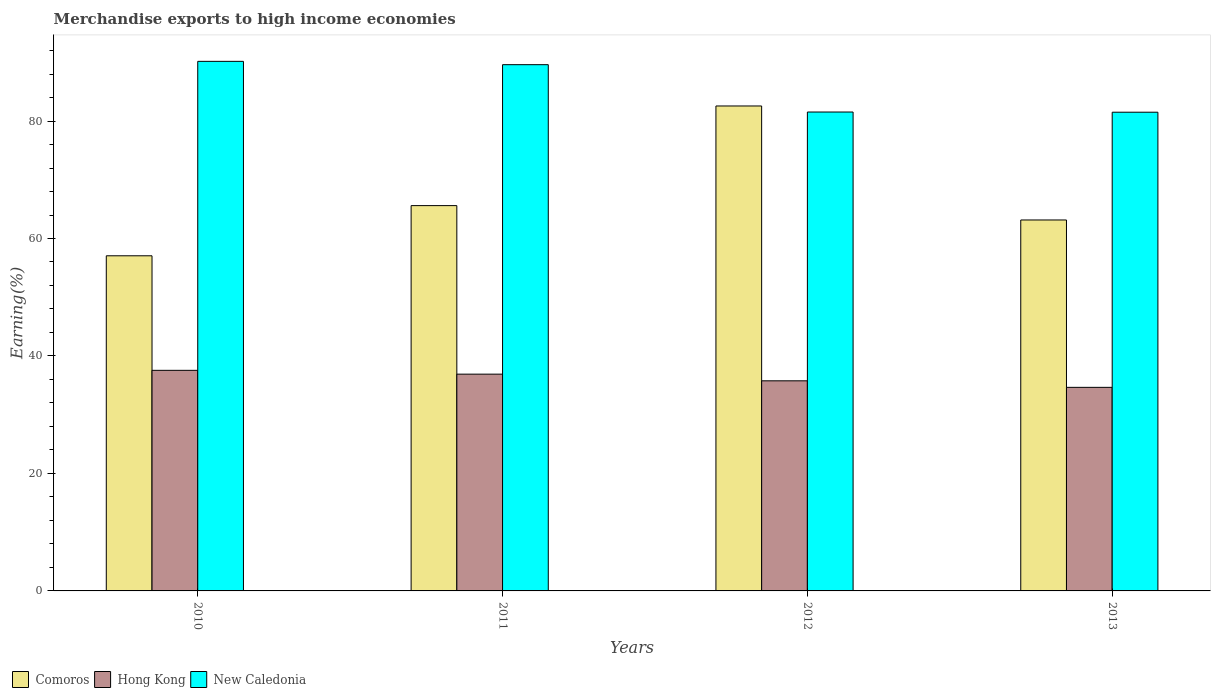How many different coloured bars are there?
Ensure brevity in your answer.  3. What is the label of the 2nd group of bars from the left?
Ensure brevity in your answer.  2011. What is the percentage of amount earned from merchandise exports in Hong Kong in 2011?
Provide a short and direct response. 36.91. Across all years, what is the maximum percentage of amount earned from merchandise exports in Comoros?
Make the answer very short. 82.56. Across all years, what is the minimum percentage of amount earned from merchandise exports in Comoros?
Keep it short and to the point. 57.06. What is the total percentage of amount earned from merchandise exports in Hong Kong in the graph?
Your answer should be compact. 144.89. What is the difference between the percentage of amount earned from merchandise exports in Comoros in 2011 and that in 2012?
Your answer should be very brief. -16.96. What is the difference between the percentage of amount earned from merchandise exports in Hong Kong in 2011 and the percentage of amount earned from merchandise exports in Comoros in 2010?
Offer a very short reply. -20.15. What is the average percentage of amount earned from merchandise exports in New Caledonia per year?
Your response must be concise. 85.7. In the year 2011, what is the difference between the percentage of amount earned from merchandise exports in New Caledonia and percentage of amount earned from merchandise exports in Hong Kong?
Your response must be concise. 52.69. What is the ratio of the percentage of amount earned from merchandise exports in New Caledonia in 2011 to that in 2013?
Your answer should be compact. 1.1. Is the percentage of amount earned from merchandise exports in Hong Kong in 2011 less than that in 2012?
Offer a very short reply. No. What is the difference between the highest and the second highest percentage of amount earned from merchandise exports in Comoros?
Make the answer very short. 16.96. What is the difference between the highest and the lowest percentage of amount earned from merchandise exports in Hong Kong?
Ensure brevity in your answer.  2.9. Is the sum of the percentage of amount earned from merchandise exports in Comoros in 2010 and 2013 greater than the maximum percentage of amount earned from merchandise exports in Hong Kong across all years?
Keep it short and to the point. Yes. What does the 1st bar from the left in 2012 represents?
Provide a succinct answer. Comoros. What does the 1st bar from the right in 2013 represents?
Your response must be concise. New Caledonia. How many bars are there?
Make the answer very short. 12. Are all the bars in the graph horizontal?
Make the answer very short. No. Are the values on the major ticks of Y-axis written in scientific E-notation?
Offer a terse response. No. How are the legend labels stacked?
Your response must be concise. Horizontal. What is the title of the graph?
Your response must be concise. Merchandise exports to high income economies. What is the label or title of the X-axis?
Offer a terse response. Years. What is the label or title of the Y-axis?
Ensure brevity in your answer.  Earning(%). What is the Earning(%) of Comoros in 2010?
Provide a succinct answer. 57.06. What is the Earning(%) in Hong Kong in 2010?
Give a very brief answer. 37.55. What is the Earning(%) in New Caledonia in 2010?
Ensure brevity in your answer.  90.16. What is the Earning(%) of Comoros in 2011?
Your response must be concise. 65.6. What is the Earning(%) of Hong Kong in 2011?
Provide a short and direct response. 36.91. What is the Earning(%) of New Caledonia in 2011?
Your answer should be compact. 89.59. What is the Earning(%) of Comoros in 2012?
Your answer should be compact. 82.56. What is the Earning(%) of Hong Kong in 2012?
Offer a very short reply. 35.77. What is the Earning(%) in New Caledonia in 2012?
Provide a succinct answer. 81.53. What is the Earning(%) in Comoros in 2013?
Offer a terse response. 63.15. What is the Earning(%) of Hong Kong in 2013?
Your response must be concise. 34.66. What is the Earning(%) in New Caledonia in 2013?
Your response must be concise. 81.5. Across all years, what is the maximum Earning(%) in Comoros?
Keep it short and to the point. 82.56. Across all years, what is the maximum Earning(%) of Hong Kong?
Offer a very short reply. 37.55. Across all years, what is the maximum Earning(%) in New Caledonia?
Provide a short and direct response. 90.16. Across all years, what is the minimum Earning(%) of Comoros?
Your answer should be compact. 57.06. Across all years, what is the minimum Earning(%) in Hong Kong?
Offer a very short reply. 34.66. Across all years, what is the minimum Earning(%) of New Caledonia?
Offer a terse response. 81.5. What is the total Earning(%) in Comoros in the graph?
Your answer should be very brief. 268.37. What is the total Earning(%) in Hong Kong in the graph?
Your response must be concise. 144.89. What is the total Earning(%) of New Caledonia in the graph?
Your answer should be compact. 342.79. What is the difference between the Earning(%) of Comoros in 2010 and that in 2011?
Keep it short and to the point. -8.54. What is the difference between the Earning(%) in Hong Kong in 2010 and that in 2011?
Ensure brevity in your answer.  0.65. What is the difference between the Earning(%) of New Caledonia in 2010 and that in 2011?
Make the answer very short. 0.57. What is the difference between the Earning(%) of Comoros in 2010 and that in 2012?
Your response must be concise. -25.51. What is the difference between the Earning(%) in Hong Kong in 2010 and that in 2012?
Your response must be concise. 1.78. What is the difference between the Earning(%) of New Caledonia in 2010 and that in 2012?
Your answer should be compact. 8.63. What is the difference between the Earning(%) of Comoros in 2010 and that in 2013?
Your answer should be compact. -6.1. What is the difference between the Earning(%) in Hong Kong in 2010 and that in 2013?
Offer a terse response. 2.9. What is the difference between the Earning(%) in New Caledonia in 2010 and that in 2013?
Keep it short and to the point. 8.66. What is the difference between the Earning(%) of Comoros in 2011 and that in 2012?
Your response must be concise. -16.96. What is the difference between the Earning(%) in Hong Kong in 2011 and that in 2012?
Your answer should be compact. 1.13. What is the difference between the Earning(%) in New Caledonia in 2011 and that in 2012?
Keep it short and to the point. 8.06. What is the difference between the Earning(%) of Comoros in 2011 and that in 2013?
Your answer should be compact. 2.45. What is the difference between the Earning(%) in Hong Kong in 2011 and that in 2013?
Keep it short and to the point. 2.25. What is the difference between the Earning(%) of New Caledonia in 2011 and that in 2013?
Make the answer very short. 8.09. What is the difference between the Earning(%) of Comoros in 2012 and that in 2013?
Your answer should be very brief. 19.41. What is the difference between the Earning(%) of Hong Kong in 2012 and that in 2013?
Offer a terse response. 1.11. What is the difference between the Earning(%) in New Caledonia in 2012 and that in 2013?
Ensure brevity in your answer.  0.03. What is the difference between the Earning(%) of Comoros in 2010 and the Earning(%) of Hong Kong in 2011?
Your answer should be very brief. 20.15. What is the difference between the Earning(%) in Comoros in 2010 and the Earning(%) in New Caledonia in 2011?
Your response must be concise. -32.54. What is the difference between the Earning(%) of Hong Kong in 2010 and the Earning(%) of New Caledonia in 2011?
Your response must be concise. -52.04. What is the difference between the Earning(%) in Comoros in 2010 and the Earning(%) in Hong Kong in 2012?
Your response must be concise. 21.28. What is the difference between the Earning(%) of Comoros in 2010 and the Earning(%) of New Caledonia in 2012?
Make the answer very short. -24.48. What is the difference between the Earning(%) in Hong Kong in 2010 and the Earning(%) in New Caledonia in 2012?
Your answer should be compact. -43.98. What is the difference between the Earning(%) in Comoros in 2010 and the Earning(%) in Hong Kong in 2013?
Your response must be concise. 22.4. What is the difference between the Earning(%) of Comoros in 2010 and the Earning(%) of New Caledonia in 2013?
Ensure brevity in your answer.  -24.44. What is the difference between the Earning(%) of Hong Kong in 2010 and the Earning(%) of New Caledonia in 2013?
Give a very brief answer. -43.95. What is the difference between the Earning(%) in Comoros in 2011 and the Earning(%) in Hong Kong in 2012?
Ensure brevity in your answer.  29.83. What is the difference between the Earning(%) in Comoros in 2011 and the Earning(%) in New Caledonia in 2012?
Offer a terse response. -15.93. What is the difference between the Earning(%) in Hong Kong in 2011 and the Earning(%) in New Caledonia in 2012?
Your answer should be very brief. -44.63. What is the difference between the Earning(%) of Comoros in 2011 and the Earning(%) of Hong Kong in 2013?
Provide a short and direct response. 30.94. What is the difference between the Earning(%) of Comoros in 2011 and the Earning(%) of New Caledonia in 2013?
Keep it short and to the point. -15.9. What is the difference between the Earning(%) of Hong Kong in 2011 and the Earning(%) of New Caledonia in 2013?
Your answer should be compact. -44.59. What is the difference between the Earning(%) of Comoros in 2012 and the Earning(%) of Hong Kong in 2013?
Your answer should be compact. 47.9. What is the difference between the Earning(%) of Comoros in 2012 and the Earning(%) of New Caledonia in 2013?
Keep it short and to the point. 1.06. What is the difference between the Earning(%) in Hong Kong in 2012 and the Earning(%) in New Caledonia in 2013?
Give a very brief answer. -45.73. What is the average Earning(%) of Comoros per year?
Your answer should be very brief. 67.09. What is the average Earning(%) in Hong Kong per year?
Offer a terse response. 36.22. What is the average Earning(%) in New Caledonia per year?
Your answer should be compact. 85.7. In the year 2010, what is the difference between the Earning(%) in Comoros and Earning(%) in Hong Kong?
Provide a succinct answer. 19.5. In the year 2010, what is the difference between the Earning(%) in Comoros and Earning(%) in New Caledonia?
Make the answer very short. -33.1. In the year 2010, what is the difference between the Earning(%) of Hong Kong and Earning(%) of New Caledonia?
Keep it short and to the point. -52.6. In the year 2011, what is the difference between the Earning(%) in Comoros and Earning(%) in Hong Kong?
Provide a short and direct response. 28.69. In the year 2011, what is the difference between the Earning(%) of Comoros and Earning(%) of New Caledonia?
Offer a very short reply. -23.99. In the year 2011, what is the difference between the Earning(%) in Hong Kong and Earning(%) in New Caledonia?
Your response must be concise. -52.69. In the year 2012, what is the difference between the Earning(%) of Comoros and Earning(%) of Hong Kong?
Make the answer very short. 46.79. In the year 2012, what is the difference between the Earning(%) of Comoros and Earning(%) of New Caledonia?
Provide a short and direct response. 1.03. In the year 2012, what is the difference between the Earning(%) of Hong Kong and Earning(%) of New Caledonia?
Ensure brevity in your answer.  -45.76. In the year 2013, what is the difference between the Earning(%) in Comoros and Earning(%) in Hong Kong?
Your answer should be compact. 28.49. In the year 2013, what is the difference between the Earning(%) of Comoros and Earning(%) of New Caledonia?
Your response must be concise. -18.35. In the year 2013, what is the difference between the Earning(%) of Hong Kong and Earning(%) of New Caledonia?
Ensure brevity in your answer.  -46.84. What is the ratio of the Earning(%) in Comoros in 2010 to that in 2011?
Ensure brevity in your answer.  0.87. What is the ratio of the Earning(%) in Hong Kong in 2010 to that in 2011?
Give a very brief answer. 1.02. What is the ratio of the Earning(%) of New Caledonia in 2010 to that in 2011?
Your answer should be compact. 1.01. What is the ratio of the Earning(%) in Comoros in 2010 to that in 2012?
Your answer should be compact. 0.69. What is the ratio of the Earning(%) in Hong Kong in 2010 to that in 2012?
Offer a terse response. 1.05. What is the ratio of the Earning(%) in New Caledonia in 2010 to that in 2012?
Keep it short and to the point. 1.11. What is the ratio of the Earning(%) in Comoros in 2010 to that in 2013?
Your answer should be very brief. 0.9. What is the ratio of the Earning(%) of Hong Kong in 2010 to that in 2013?
Your answer should be very brief. 1.08. What is the ratio of the Earning(%) of New Caledonia in 2010 to that in 2013?
Your answer should be very brief. 1.11. What is the ratio of the Earning(%) in Comoros in 2011 to that in 2012?
Your answer should be compact. 0.79. What is the ratio of the Earning(%) of Hong Kong in 2011 to that in 2012?
Your response must be concise. 1.03. What is the ratio of the Earning(%) of New Caledonia in 2011 to that in 2012?
Offer a very short reply. 1.1. What is the ratio of the Earning(%) in Comoros in 2011 to that in 2013?
Keep it short and to the point. 1.04. What is the ratio of the Earning(%) of Hong Kong in 2011 to that in 2013?
Ensure brevity in your answer.  1.06. What is the ratio of the Earning(%) of New Caledonia in 2011 to that in 2013?
Your answer should be very brief. 1.1. What is the ratio of the Earning(%) in Comoros in 2012 to that in 2013?
Your answer should be very brief. 1.31. What is the ratio of the Earning(%) of Hong Kong in 2012 to that in 2013?
Keep it short and to the point. 1.03. What is the difference between the highest and the second highest Earning(%) in Comoros?
Ensure brevity in your answer.  16.96. What is the difference between the highest and the second highest Earning(%) in Hong Kong?
Make the answer very short. 0.65. What is the difference between the highest and the second highest Earning(%) in New Caledonia?
Offer a very short reply. 0.57. What is the difference between the highest and the lowest Earning(%) of Comoros?
Keep it short and to the point. 25.51. What is the difference between the highest and the lowest Earning(%) of Hong Kong?
Your response must be concise. 2.9. What is the difference between the highest and the lowest Earning(%) in New Caledonia?
Ensure brevity in your answer.  8.66. 